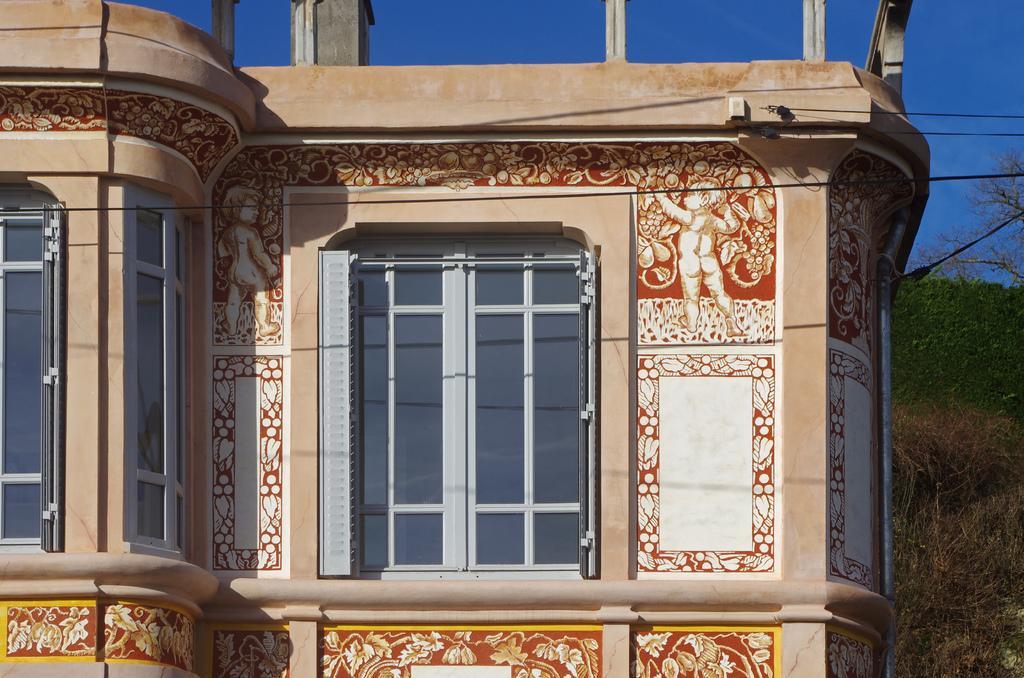Describe this image in one or two sentences. In this image I can see a building along with the windows. On the right side there are some trees. On the top of the image I can see the sky and some wires. 